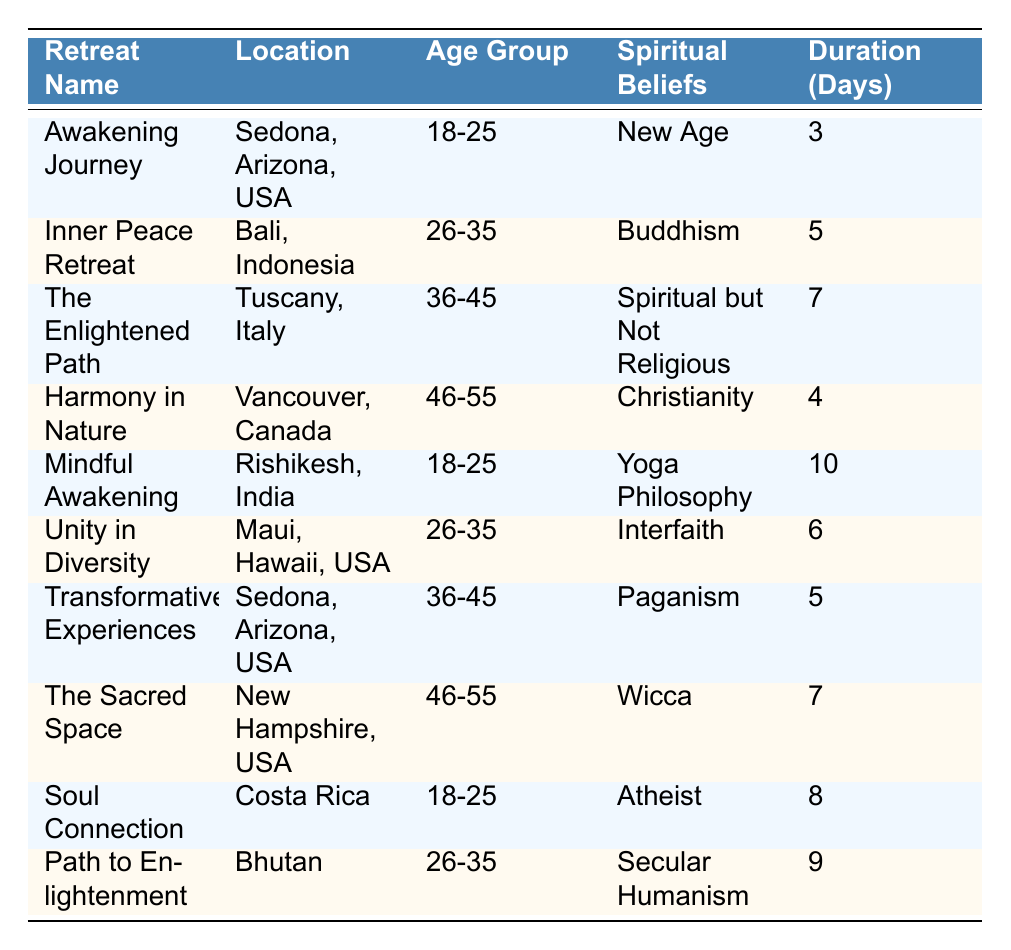What is the duration of the "Mindful Awakening" retreat? The table lists the "Mindful Awakening" retreat, and the duration provided is 10 days.
Answer: 10 days Which age group has the most representatives in the table? The age groups listed are 18-25, 26-35, 36-45, and 46-55. The 18-25 age group appears 3 times, while the others appear fewer times.
Answer: 18-25 How many retreats last for more than 6 days? By reviewing the duration of each retreat, the "Mindful Awakening" (10 days), "Path to Enlightenment" (9 days), and "The Enlightened Path" (7 days) are the only ones lasting more than 6 days. So, there are 3 retreats.
Answer: 3 Is there a retreat in the table that has "Christianity" as a spiritual belief? Yes, the "Harmony in Nature" retreat is listed under the spiritual beliefs as "Christianity."
Answer: Yes What is the average duration of retreats for the age group 26-35? The retreats for 26-35 years are "Inner Peace Retreat" (5 days), "Unity in Diversity" (6 days), and "Path to Enlightenment" (9 days). Adding these gives 20 days. Divided by 3 (the number of retreats) results in an average of 20/3 ≈ 6.67 days.
Answer: Approximately 6.67 days Are there more female or male attendees in the table? A count reveals that there are 5 females (Awakening Journey, The Enlightened Path, Unity in Diversity, The Sacred Space, Path to Enlightenment) and 4 males (Inner Peace Retreat, Harmony in Nature, Transformative Experiences, Soul Connection). So, there are more females.
Answer: More females What spiritual belief is associated with the most retreats listed in the table? Observing the spiritual beliefs, "New Age" (1), "Buddhism" (1), "Spiritual but Not Religious" (1), "Christianity" (1), "Yoga Philosophy" (1), "Interfaith" (1), "Paganism" (1), "Wicca" (1), "Atheist" (1), "Secular Humanism" (1) shows that each belief is associated with only one retreat. No belief is associated with more than one.
Answer: None How many retreats are held in Arizona? The table includes "Awakening Journey" and "Transformative Experiences," both located in Arizona. So, there are 2 retreats held there.
Answer: 2 